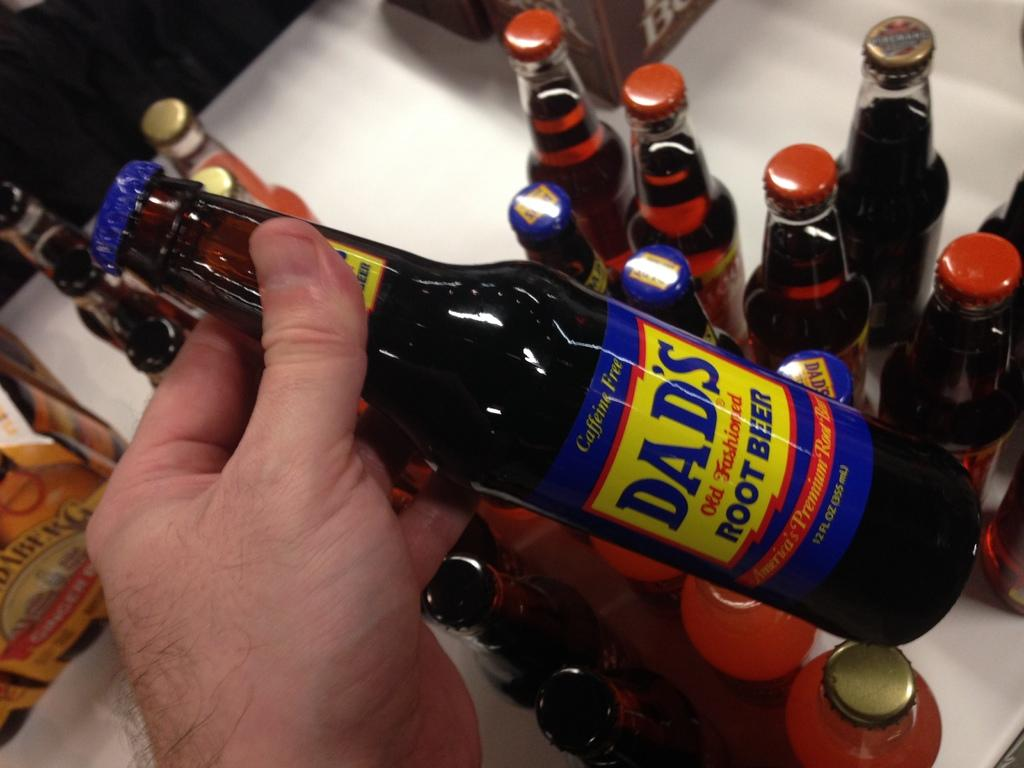What objects are present in the image? There are multiple bottles in the image. Can you describe the bottles in the image? Unfortunately, the facts provided do not give any details about the bottles, such as their size, color, or contents. Are there any other objects or people visible in the image? The facts provided do not mention any other objects or people in the image. How many pies are displayed on the vest in the image? There are no pies or vests present in the image; it only contains multiple bottles. 